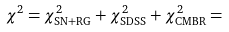Convert formula to latex. <formula><loc_0><loc_0><loc_500><loc_500>\chi ^ { 2 } = \chi _ { \text {SN+RG} } ^ { 2 } + \chi _ { \text {SDSS} } ^ { 2 } + \chi _ { \text {CMBR} } ^ { 2 } =</formula> 